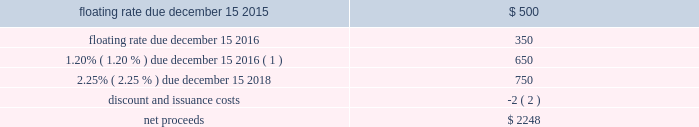Devon energy corporation and subsidiaries notes to consolidated financial statements 2013 ( continued ) other debentures and notes following are descriptions of the various other debentures and notes outstanding at december 31 , 2014 and 2013 , as listed in the table presented at the beginning of this note .
Geosouthern debt in december 2013 , in conjunction with the planned geosouthern acquisition , devon issued $ 2.25 billion aggregate principal amount of fixed and floating rate senior notes resulting in cash proceeds of approximately $ 2.2 billion , net of discounts and issuance costs .
The floating rate senior notes due in 2015 bear interest at a rate equal to three-month libor plus 0.45 percent , which rate will be reset quarterly .
The floating rate senior notes due in 2016 bears interest at a rate equal to three-month libor plus 0.54 percent , which rate will be reset quarterly .
The schedule below summarizes the key terms of these notes ( in millions ) . .
( 1 ) the 1.20% ( 1.20 % ) $ 650 million note due december 15 , 2016 was redeemed on november 13 , 2014 .
The senior notes were classified as short-term debt on devon 2019s consolidated balance sheet as of december 31 , 2013 due to certain redemption features in the event that the geosouthern acquisition was not completed on or prior to june 30 , 2014 .
On february 28 , 2014 , the geosouthern acquisition closed and thus the senior notes were subsequently classified as long-term debt .
Additionally , during december 2013 , devon entered into a term loan agreement with a group of major financial institutions pursuant to which devon could draw up to $ 2.0 billion to finance , in part , the geosouthern acquisition and to pay transaction costs .
In february 2014 , devon drew the $ 2.0 billion of term loans for the geosouthern transaction , and the amount was subsequently repaid on june 30 , 2014 with the canadian divestiture proceeds that were repatriated to the u.s .
In june 2014 , at which point the term loan was terminated. .
What percentage of the net proceeds came from the floating rates due in 2015 and 2016? 
Computations: (((500 + 350) / 2248) * 100)
Answer: 37.81139. 